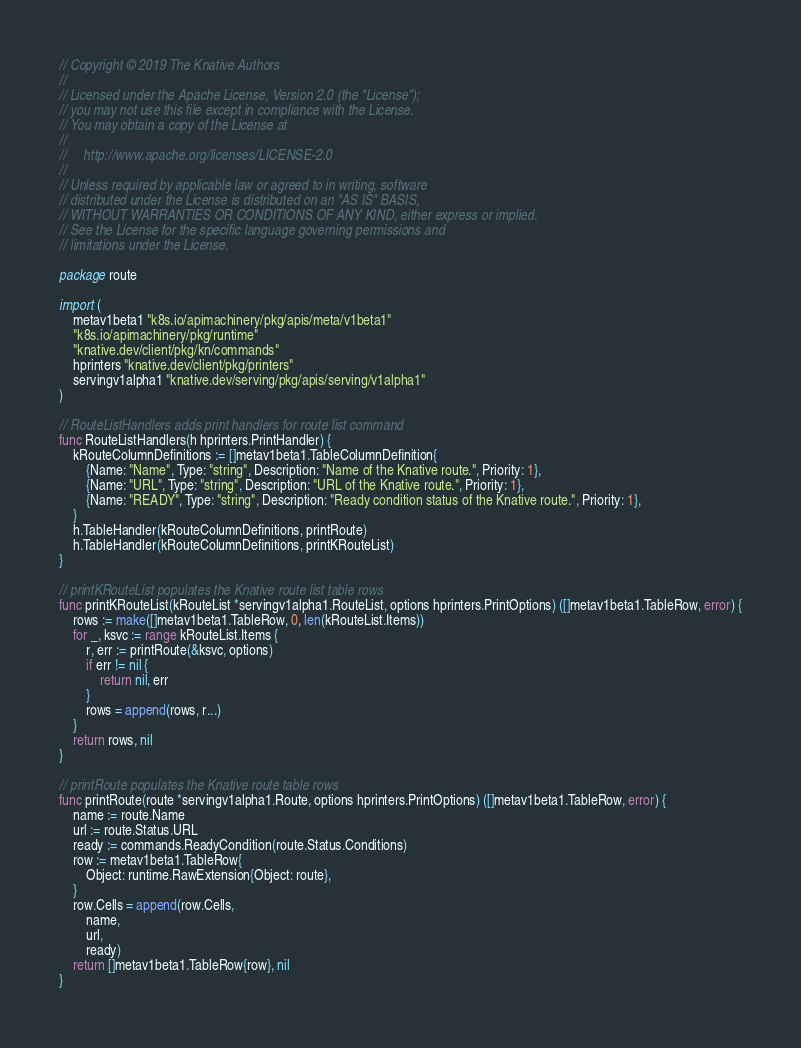Convert code to text. <code><loc_0><loc_0><loc_500><loc_500><_Go_>// Copyright © 2019 The Knative Authors
//
// Licensed under the Apache License, Version 2.0 (the "License");
// you may not use this file except in compliance with the License.
// You may obtain a copy of the License at
//
//     http://www.apache.org/licenses/LICENSE-2.0
//
// Unless required by applicable law or agreed to in writing, software
// distributed under the License is distributed on an "AS IS" BASIS,
// WITHOUT WARRANTIES OR CONDITIONS OF ANY KIND, either express or implied.
// See the License for the specific language governing permissions and
// limitations under the License.

package route

import (
	metav1beta1 "k8s.io/apimachinery/pkg/apis/meta/v1beta1"
	"k8s.io/apimachinery/pkg/runtime"
	"knative.dev/client/pkg/kn/commands"
	hprinters "knative.dev/client/pkg/printers"
	servingv1alpha1 "knative.dev/serving/pkg/apis/serving/v1alpha1"
)

// RouteListHandlers adds print handlers for route list command
func RouteListHandlers(h hprinters.PrintHandler) {
	kRouteColumnDefinitions := []metav1beta1.TableColumnDefinition{
		{Name: "Name", Type: "string", Description: "Name of the Knative route.", Priority: 1},
		{Name: "URL", Type: "string", Description: "URL of the Knative route.", Priority: 1},
		{Name: "READY", Type: "string", Description: "Ready condition status of the Knative route.", Priority: 1},
	}
	h.TableHandler(kRouteColumnDefinitions, printRoute)
	h.TableHandler(kRouteColumnDefinitions, printKRouteList)
}

// printKRouteList populates the Knative route list table rows
func printKRouteList(kRouteList *servingv1alpha1.RouteList, options hprinters.PrintOptions) ([]metav1beta1.TableRow, error) {
	rows := make([]metav1beta1.TableRow, 0, len(kRouteList.Items))
	for _, ksvc := range kRouteList.Items {
		r, err := printRoute(&ksvc, options)
		if err != nil {
			return nil, err
		}
		rows = append(rows, r...)
	}
	return rows, nil
}

// printRoute populates the Knative route table rows
func printRoute(route *servingv1alpha1.Route, options hprinters.PrintOptions) ([]metav1beta1.TableRow, error) {
	name := route.Name
	url := route.Status.URL
	ready := commands.ReadyCondition(route.Status.Conditions)
	row := metav1beta1.TableRow{
		Object: runtime.RawExtension{Object: route},
	}
	row.Cells = append(row.Cells,
		name,
		url,
		ready)
	return []metav1beta1.TableRow{row}, nil
}
</code> 